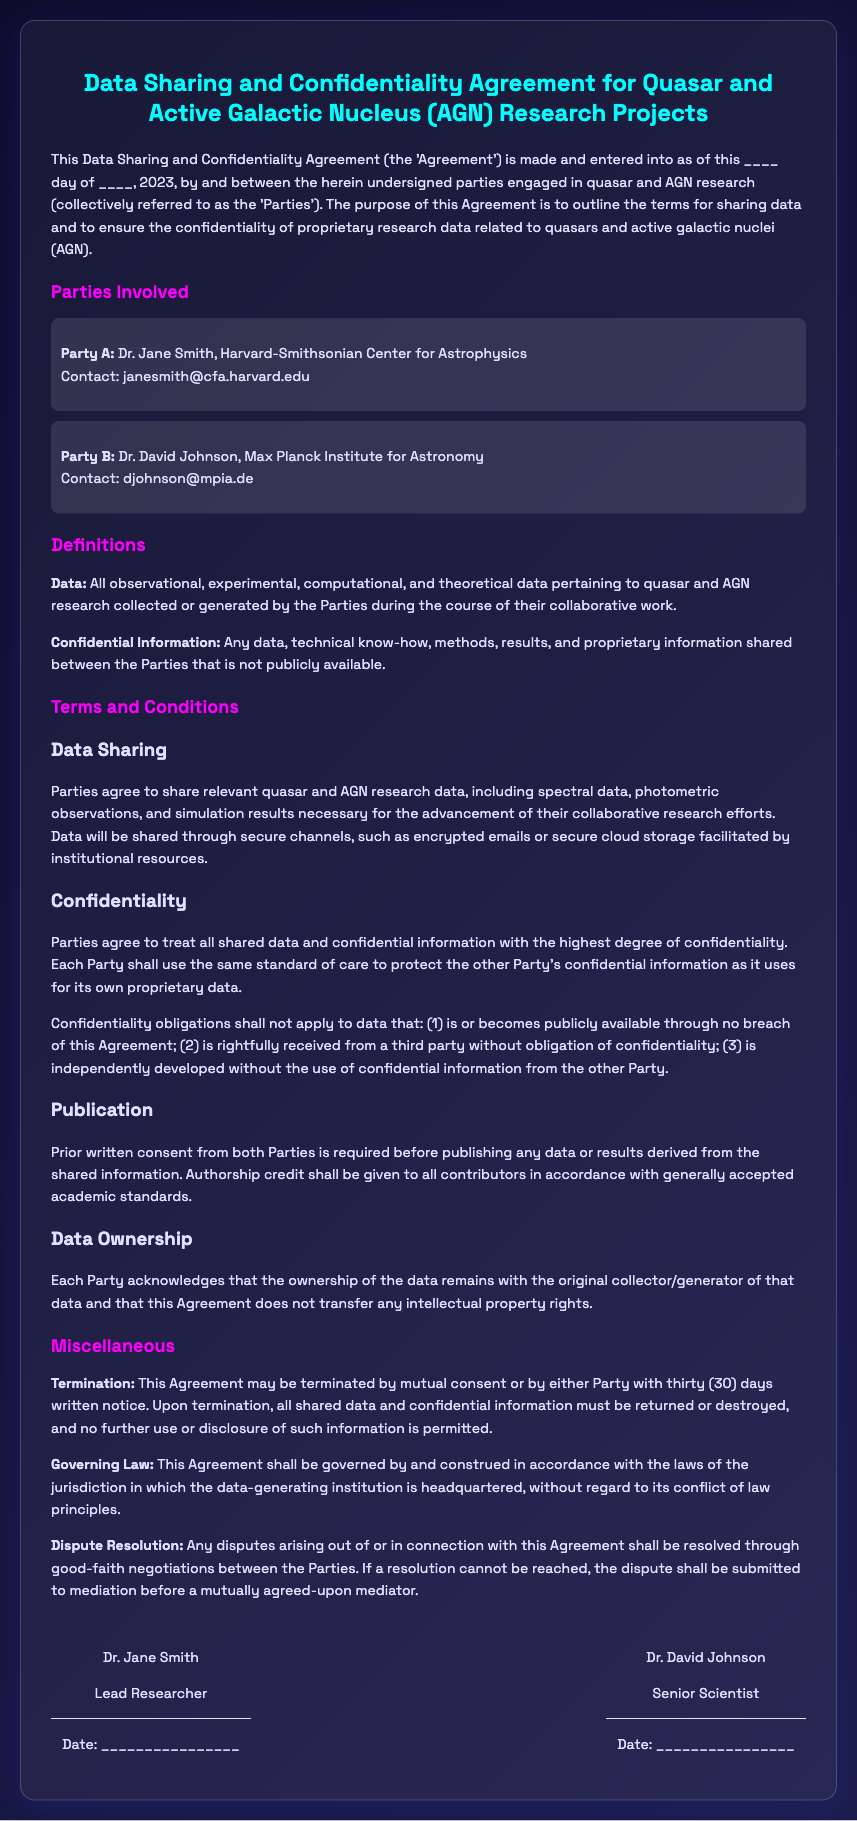What is the title of the document? The title is stated at the top and outlines the main subject of the document, which is the agreement regarding data sharing and confidentiality.
Answer: Data Sharing and Confidentiality Agreement for Quasar and Active Galactic Nucleus (AGN) Research Projects Who is Party A? Party A is listed in the Parties Involved section, providing a name and affiliation.
Answer: Dr. Jane Smith, Harvard-Smithsonian Center for Astrophysics Who is Party B? Party B is also listed in the Parties Involved section, providing similar details as Party A.
Answer: Dr. David Johnson, Max Planck Institute for Astronomy What is defined as "Confidential Information"? Confidential Information is defined clearly in the section dedicated to definitions within the document.
Answer: Any data, technical know-how, methods, results, and proprietary information shared that is not publicly available What data may be shared according to the terms? The document specifies the types of data covered under the data sharing agreement, outlining their relevance to research.
Answer: Spectral data, photometric observations, and simulation results What is required before publishing research results? The publication section specifies an action that must be taken prior to dissemination of research findings.
Answer: Prior written consent from both Parties How long is the notice period for termination of the Agreement? The termination section outlines the necessary period before either Party can terminate the agreement.
Answer: Thirty (30) days What is mentioned about data ownership? The data ownership clause describes the rights of the original data collector in the agreement.
Answer: Ownership remains with the original collector/generator of that data What is the method for resolving disputes? The document outlines a specific approach for handling conflicts between the Parties.
Answer: Good-faith negotiations followed by mediation 